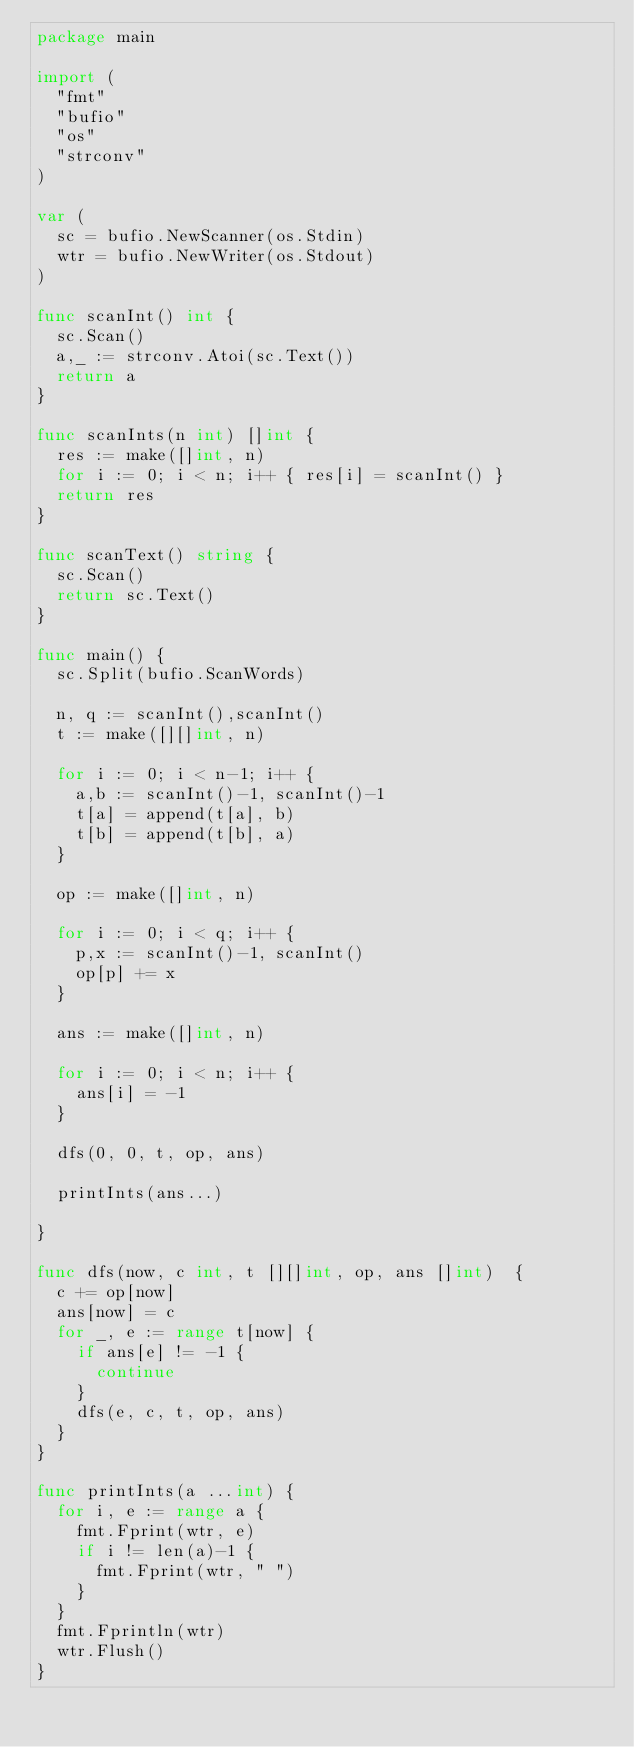<code> <loc_0><loc_0><loc_500><loc_500><_Go_>package main

import (
	"fmt"
	"bufio"
	"os"
	"strconv"
)

var (
	sc = bufio.NewScanner(os.Stdin)
	wtr = bufio.NewWriter(os.Stdout)
)

func scanInt() int {
	sc.Scan()
	a,_ := strconv.Atoi(sc.Text())
	return a
}

func scanInts(n int) []int {
	res := make([]int, n)
	for i := 0; i < n; i++ { res[i] = scanInt() }
	return res
}

func scanText() string {
	sc.Scan()
	return sc.Text()
}

func main() {
	sc.Split(bufio.ScanWords)

	n, q := scanInt(),scanInt()
	t := make([][]int, n)

	for i := 0; i < n-1; i++ {
		a,b := scanInt()-1, scanInt()-1
		t[a] = append(t[a], b)
		t[b] = append(t[b], a)
	}

	op := make([]int, n)

	for i := 0; i < q; i++ {
		p,x := scanInt()-1, scanInt()
		op[p] += x
	}

	ans := make([]int, n)

	for i := 0; i < n; i++ {
		ans[i] = -1
	}

	dfs(0, 0, t, op, ans)

	printInts(ans...)

}

func dfs(now, c int, t [][]int, op, ans []int)  {
	c += op[now]
	ans[now] = c
	for _, e := range t[now] {
		if ans[e] != -1 {
			continue
		}
		dfs(e, c, t, op, ans)
	}
}

func printInts(a ...int) {
	for i, e := range a {
		fmt.Fprint(wtr, e)
		if i != len(a)-1 {
			fmt.Fprint(wtr, " ")
		}
	}
	fmt.Fprintln(wtr)
	wtr.Flush()
}
</code> 